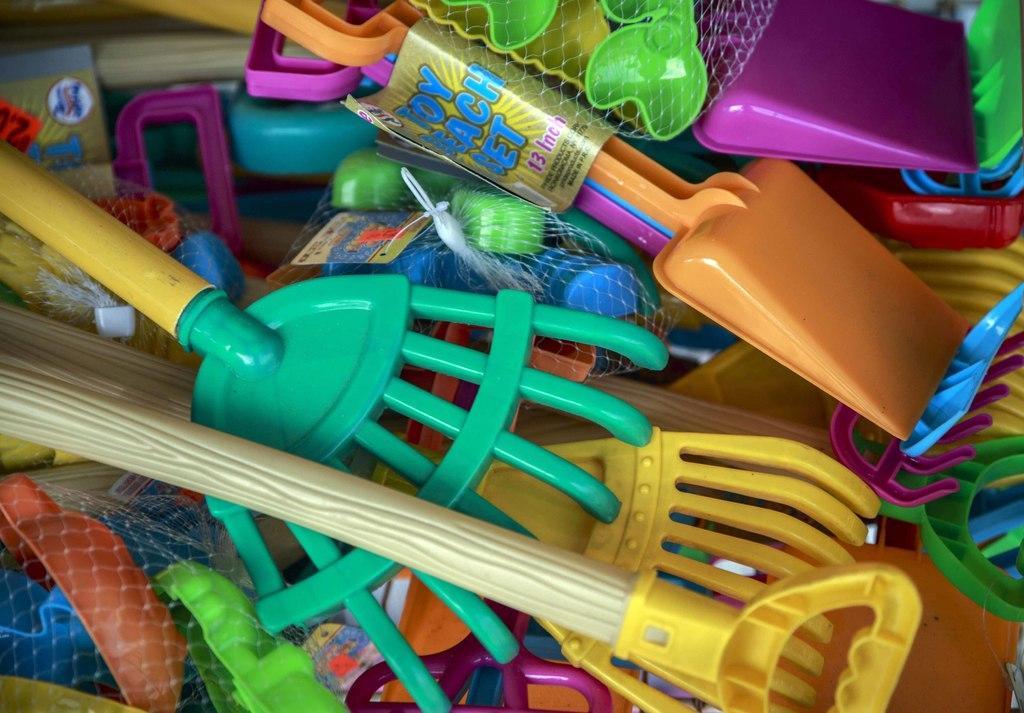Please provide a concise description of this image. In this image we can see a group of plastic objects. There are few nets and tags. On the tags we can see some text. 